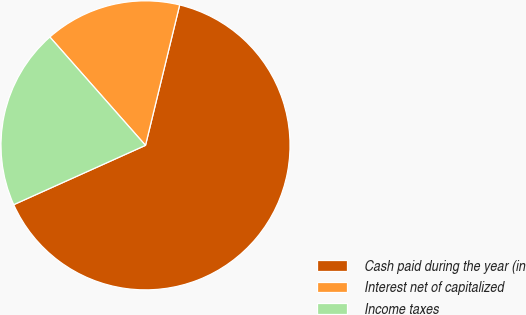Convert chart to OTSL. <chart><loc_0><loc_0><loc_500><loc_500><pie_chart><fcel>Cash paid during the year (in<fcel>Interest net of capitalized<fcel>Income taxes<nl><fcel>64.47%<fcel>15.31%<fcel>20.22%<nl></chart> 